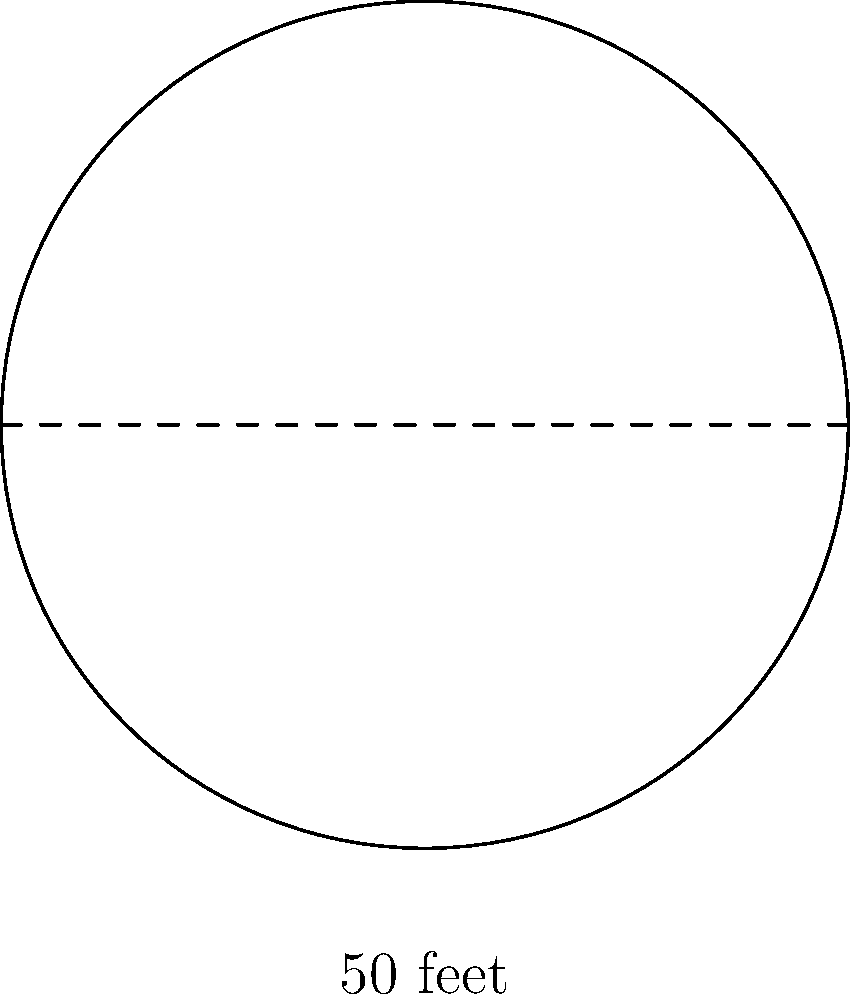You've decided to build a circular horse training pen on your ranch. If the diameter of the pen is 50 feet, what is the area of the pen in square feet? Round your answer to the nearest whole number. Let's approach this step-by-step:

1) First, recall the formula for the area of a circle:
   $$A = \pi r^2$$
   where $A$ is the area and $r$ is the radius.

2) We're given the diameter, which is 50 feet. The radius is half of the diameter:
   $$r = \frac{50}{2} = 25\text{ feet}$$

3) Now, let's substitute this into our area formula:
   $$A = \pi (25)^2$$

4) Simplify:
   $$A = 625\pi\text{ square feet}$$

5) Using 3.14159 as an approximation for $\pi$:
   $$A \approx 625 \times 3.14159 = 1963.49375\text{ square feet}$$

6) Rounding to the nearest whole number:
   $$A \approx 1963\text{ square feet}$$
Answer: 1963 square feet 